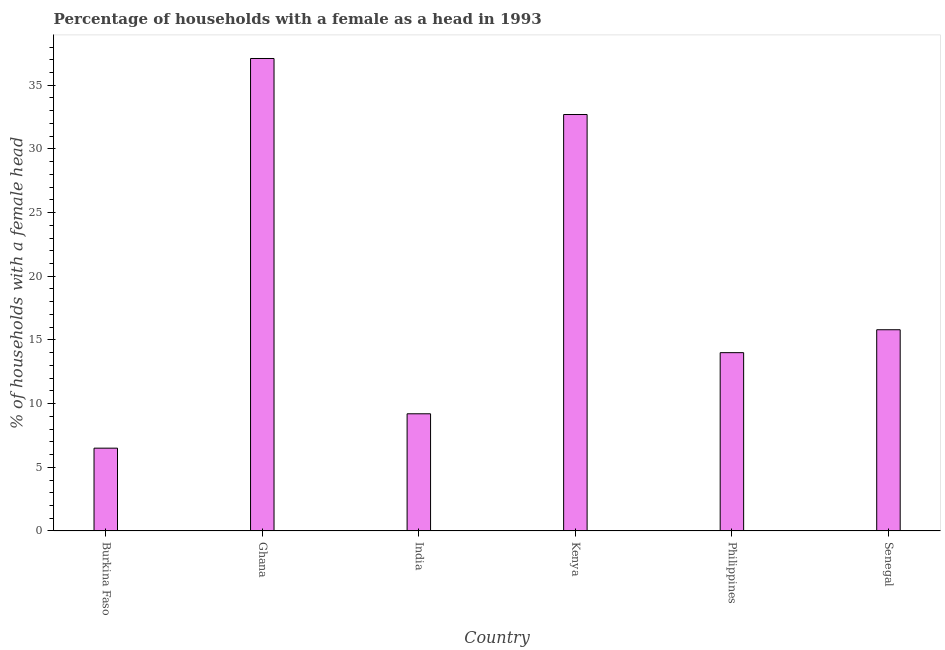What is the title of the graph?
Provide a succinct answer. Percentage of households with a female as a head in 1993. What is the label or title of the Y-axis?
Offer a very short reply. % of households with a female head. What is the number of female supervised households in Senegal?
Provide a short and direct response. 15.8. Across all countries, what is the maximum number of female supervised households?
Ensure brevity in your answer.  37.1. In which country was the number of female supervised households maximum?
Your answer should be compact. Ghana. In which country was the number of female supervised households minimum?
Offer a very short reply. Burkina Faso. What is the sum of the number of female supervised households?
Your response must be concise. 115.3. What is the difference between the number of female supervised households in Burkina Faso and Senegal?
Offer a very short reply. -9.3. What is the average number of female supervised households per country?
Provide a short and direct response. 19.22. What is the median number of female supervised households?
Provide a succinct answer. 14.9. In how many countries, is the number of female supervised households greater than 37 %?
Your answer should be very brief. 1. What is the ratio of the number of female supervised households in Burkina Faso to that in Senegal?
Your answer should be compact. 0.41. Is the difference between the number of female supervised households in Burkina Faso and Kenya greater than the difference between any two countries?
Keep it short and to the point. No. What is the difference between the highest and the lowest number of female supervised households?
Give a very brief answer. 30.6. In how many countries, is the number of female supervised households greater than the average number of female supervised households taken over all countries?
Offer a terse response. 2. How many bars are there?
Keep it short and to the point. 6. Are all the bars in the graph horizontal?
Provide a succinct answer. No. What is the % of households with a female head in Ghana?
Keep it short and to the point. 37.1. What is the % of households with a female head of India?
Make the answer very short. 9.2. What is the % of households with a female head of Kenya?
Provide a short and direct response. 32.7. What is the % of households with a female head of Philippines?
Give a very brief answer. 14. What is the difference between the % of households with a female head in Burkina Faso and Ghana?
Provide a short and direct response. -30.6. What is the difference between the % of households with a female head in Burkina Faso and Kenya?
Offer a very short reply. -26.2. What is the difference between the % of households with a female head in Ghana and India?
Offer a terse response. 27.9. What is the difference between the % of households with a female head in Ghana and Kenya?
Offer a very short reply. 4.4. What is the difference between the % of households with a female head in Ghana and Philippines?
Ensure brevity in your answer.  23.1. What is the difference between the % of households with a female head in Ghana and Senegal?
Your answer should be compact. 21.3. What is the difference between the % of households with a female head in India and Kenya?
Offer a very short reply. -23.5. What is the difference between the % of households with a female head in India and Senegal?
Keep it short and to the point. -6.6. What is the difference between the % of households with a female head in Kenya and Philippines?
Your response must be concise. 18.7. What is the difference between the % of households with a female head in Philippines and Senegal?
Provide a succinct answer. -1.8. What is the ratio of the % of households with a female head in Burkina Faso to that in Ghana?
Make the answer very short. 0.17. What is the ratio of the % of households with a female head in Burkina Faso to that in India?
Your answer should be compact. 0.71. What is the ratio of the % of households with a female head in Burkina Faso to that in Kenya?
Make the answer very short. 0.2. What is the ratio of the % of households with a female head in Burkina Faso to that in Philippines?
Your answer should be compact. 0.46. What is the ratio of the % of households with a female head in Burkina Faso to that in Senegal?
Keep it short and to the point. 0.41. What is the ratio of the % of households with a female head in Ghana to that in India?
Offer a terse response. 4.03. What is the ratio of the % of households with a female head in Ghana to that in Kenya?
Offer a terse response. 1.14. What is the ratio of the % of households with a female head in Ghana to that in Philippines?
Provide a short and direct response. 2.65. What is the ratio of the % of households with a female head in Ghana to that in Senegal?
Your answer should be very brief. 2.35. What is the ratio of the % of households with a female head in India to that in Kenya?
Give a very brief answer. 0.28. What is the ratio of the % of households with a female head in India to that in Philippines?
Offer a terse response. 0.66. What is the ratio of the % of households with a female head in India to that in Senegal?
Provide a succinct answer. 0.58. What is the ratio of the % of households with a female head in Kenya to that in Philippines?
Provide a succinct answer. 2.34. What is the ratio of the % of households with a female head in Kenya to that in Senegal?
Make the answer very short. 2.07. What is the ratio of the % of households with a female head in Philippines to that in Senegal?
Keep it short and to the point. 0.89. 